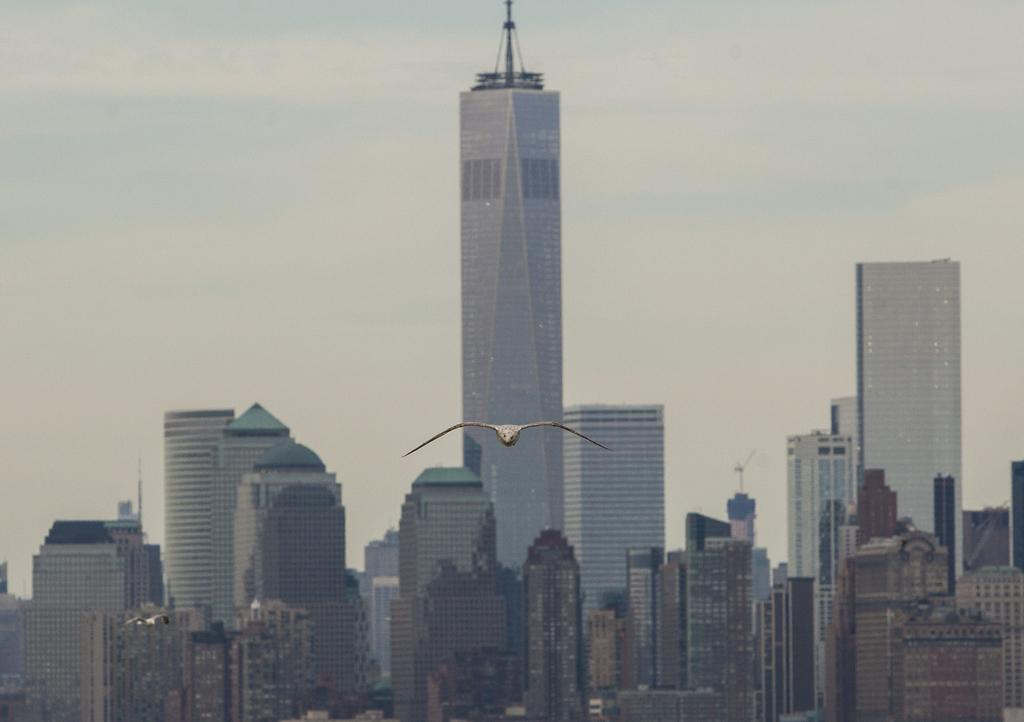What type of structures can be seen in the image? There are buildings in the image. What is happening in the sky in the image? A bird is flying in the image. What can be seen in the background of the image? The sky is visible in the background of the image. How many pets are visible in the image? There are no pets visible in the image. What type of bikes are present in the image? There are no bikes present in the image. 